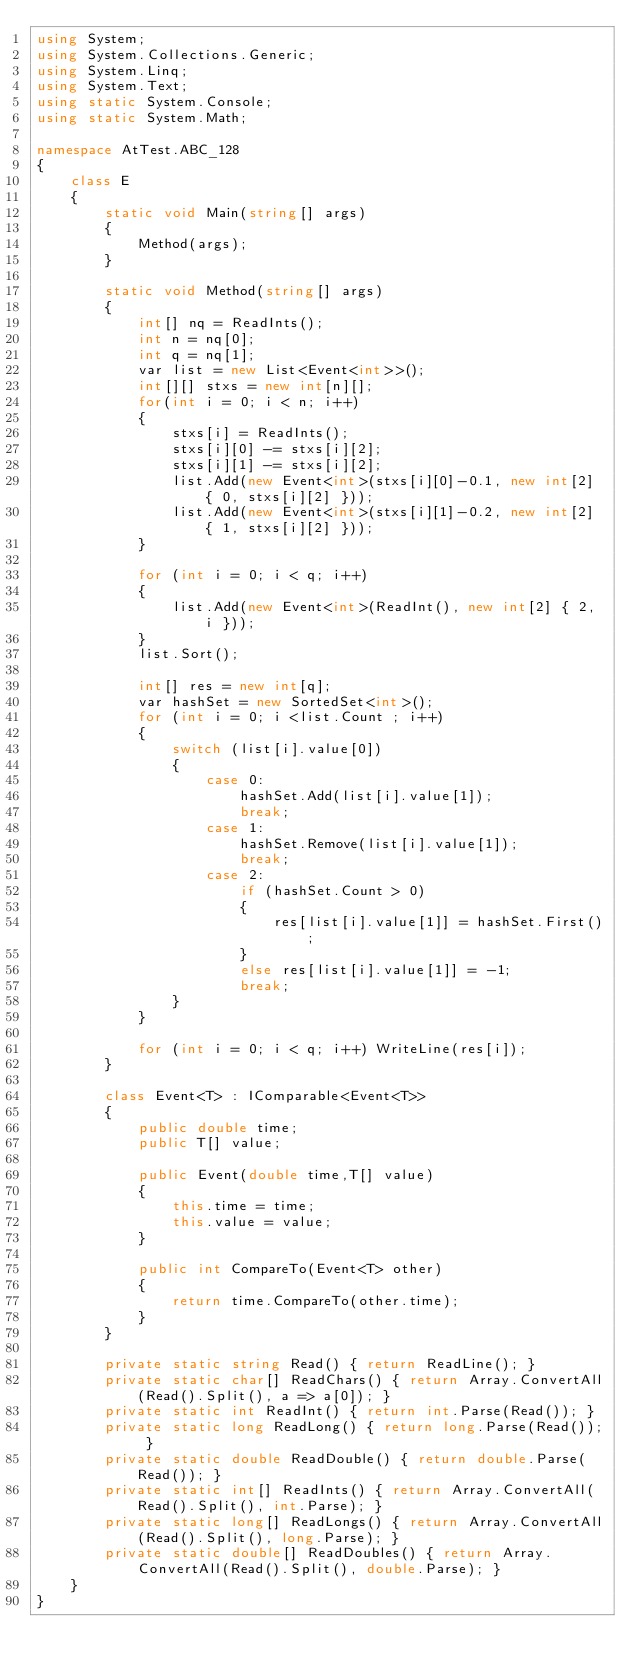<code> <loc_0><loc_0><loc_500><loc_500><_C#_>using System;
using System.Collections.Generic;
using System.Linq;
using System.Text;
using static System.Console;
using static System.Math;

namespace AtTest.ABC_128
{
    class E
    {
        static void Main(string[] args)
        {
            Method(args);
        }

        static void Method(string[] args)
        {
            int[] nq = ReadInts();
            int n = nq[0];
            int q = nq[1];
            var list = new List<Event<int>>();
            int[][] stxs = new int[n][];
            for(int i = 0; i < n; i++)
            {
                stxs[i] = ReadInts();
                stxs[i][0] -= stxs[i][2];
                stxs[i][1] -= stxs[i][2];
                list.Add(new Event<int>(stxs[i][0]-0.1, new int[2] { 0, stxs[i][2] }));
                list.Add(new Event<int>(stxs[i][1]-0.2, new int[2] { 1, stxs[i][2] }));
            }

            for (int i = 0; i < q; i++)
            {
                list.Add(new Event<int>(ReadInt(), new int[2] { 2, i }));
            }
            list.Sort();
            
            int[] res = new int[q];
            var hashSet = new SortedSet<int>();
            for (int i = 0; i <list.Count ; i++)
            {
                switch (list[i].value[0])
                {
                    case 0:
                        hashSet.Add(list[i].value[1]);
                        break;
                    case 1:
                        hashSet.Remove(list[i].value[1]);
                        break;
                    case 2:
                        if (hashSet.Count > 0)
                        {
                            res[list[i].value[1]] = hashSet.First();
                        }
                        else res[list[i].value[1]] = -1;
                        break;
                }
            }

            for (int i = 0; i < q; i++) WriteLine(res[i]);
        }

        class Event<T> : IComparable<Event<T>>
        {
            public double time;
            public T[] value;

            public Event(double time,T[] value)
            {
                this.time = time;
                this.value = value;
            }

            public int CompareTo(Event<T> other)
            {
                return time.CompareTo(other.time);
            }
        }

        private static string Read() { return ReadLine(); }
        private static char[] ReadChars() { return Array.ConvertAll(Read().Split(), a => a[0]); }
        private static int ReadInt() { return int.Parse(Read()); }
        private static long ReadLong() { return long.Parse(Read()); }
        private static double ReadDouble() { return double.Parse(Read()); }
        private static int[] ReadInts() { return Array.ConvertAll(Read().Split(), int.Parse); }
        private static long[] ReadLongs() { return Array.ConvertAll(Read().Split(), long.Parse); }
        private static double[] ReadDoubles() { return Array.ConvertAll(Read().Split(), double.Parse); }
    }
}
</code> 